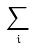Convert formula to latex. <formula><loc_0><loc_0><loc_500><loc_500>\sum _ { i }</formula> 